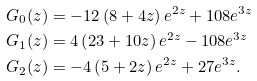Convert formula to latex. <formula><loc_0><loc_0><loc_500><loc_500>G _ { 0 } ( z ) & = - 1 2 \left ( 8 + 4 z \right ) e ^ { 2 z } + 1 0 8 e ^ { 3 z } \\ G _ { 1 } ( z ) & = 4 \left ( 2 3 + 1 0 z \right ) e ^ { 2 z } - 1 0 8 e ^ { 3 z } \\ G _ { 2 } ( z ) & = - 4 \left ( 5 + 2 z \right ) e ^ { 2 z } + 2 7 e ^ { 3 z } .</formula> 